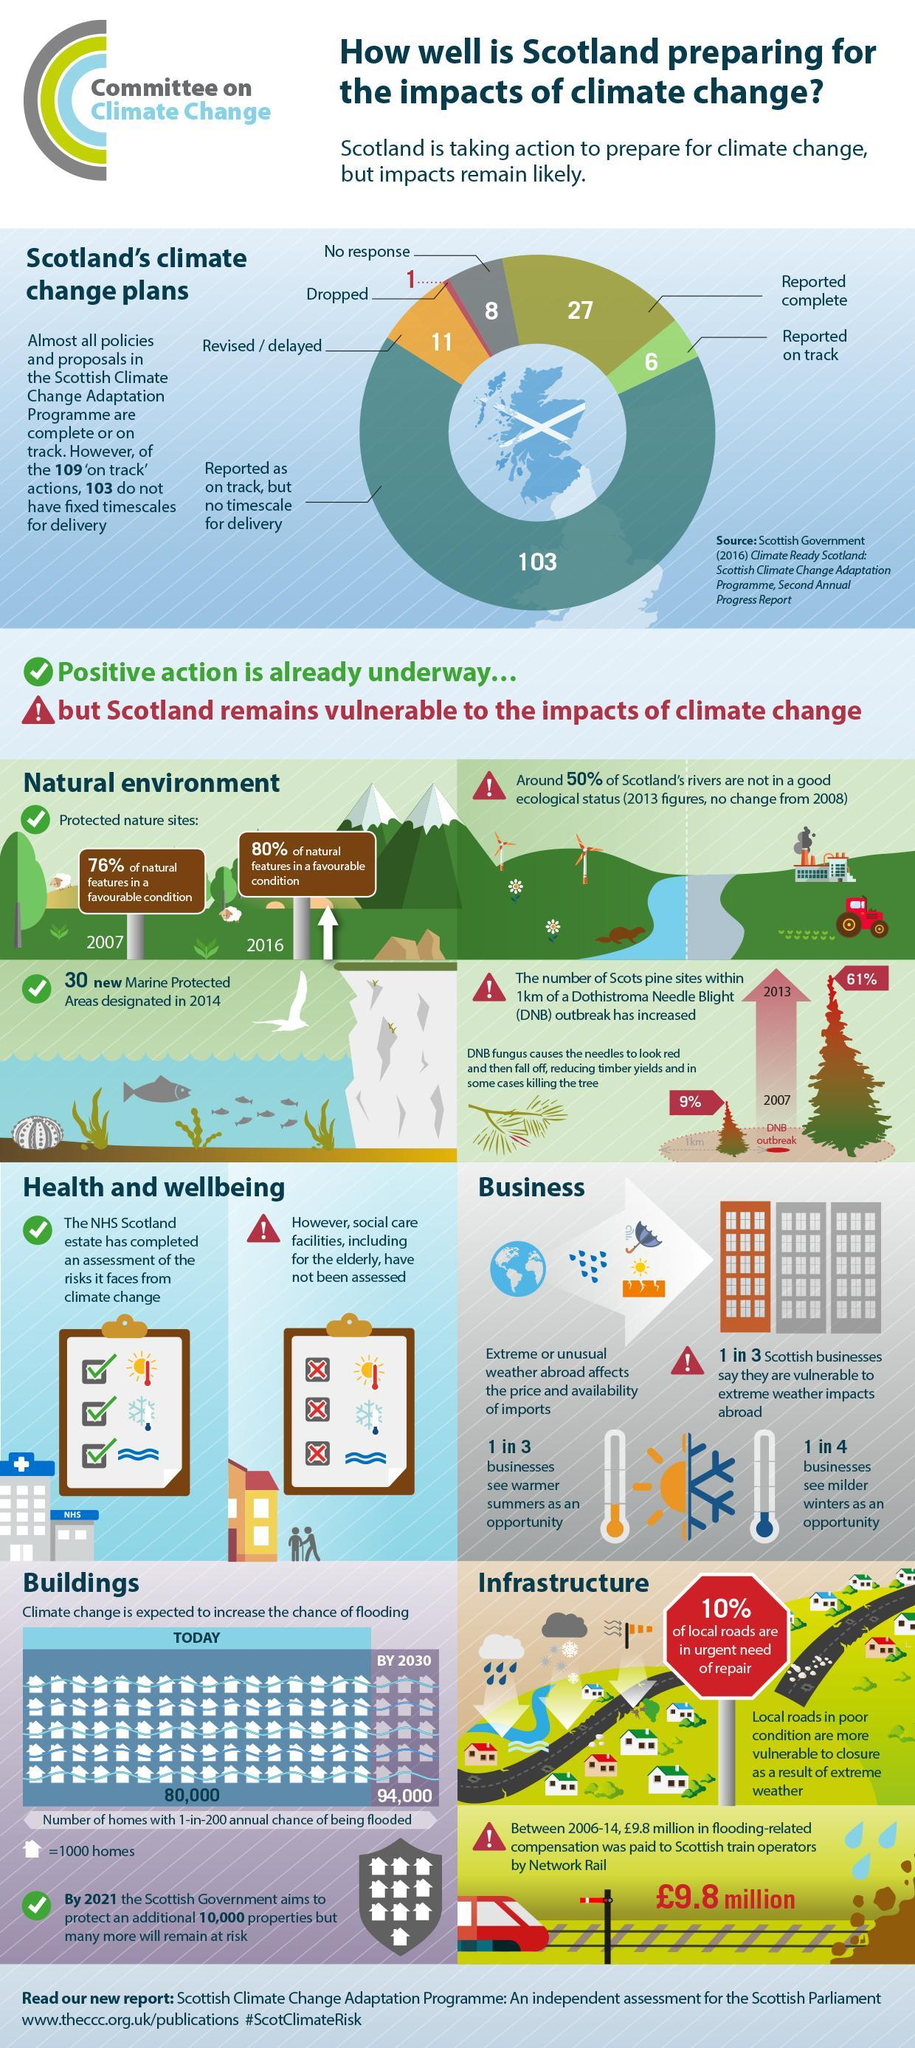How many of the policies and proposals in the Scottish climate change adaptation programme are reported as complete?
Answer the question with a short phrase. 27 What is the increase in percentage of DNB Outbreak from 2007 to 2016? 52% What percentage of Scottish businesses say they are vulnerable to extreme weather impacts abroad? 33.33% Which color represents the revised/delayed plans in the pie chart, orange, green or red? orange How many of 109 'on track' actions have fixed timescales for delivery? 6 How many of the policies and proposals in the Scottish climate change adaptation programme are dropped? 1 What is the increase in percentage of natural features in a favourable condition from 2007 to 2016? 4% Which color represents the dropped plans in the pie chart, orange, green or red? red What percentage of businesses see warmer summers as an opportunity? 33.33% What percentage of businesses see milder winters as an opportunity? 25% 